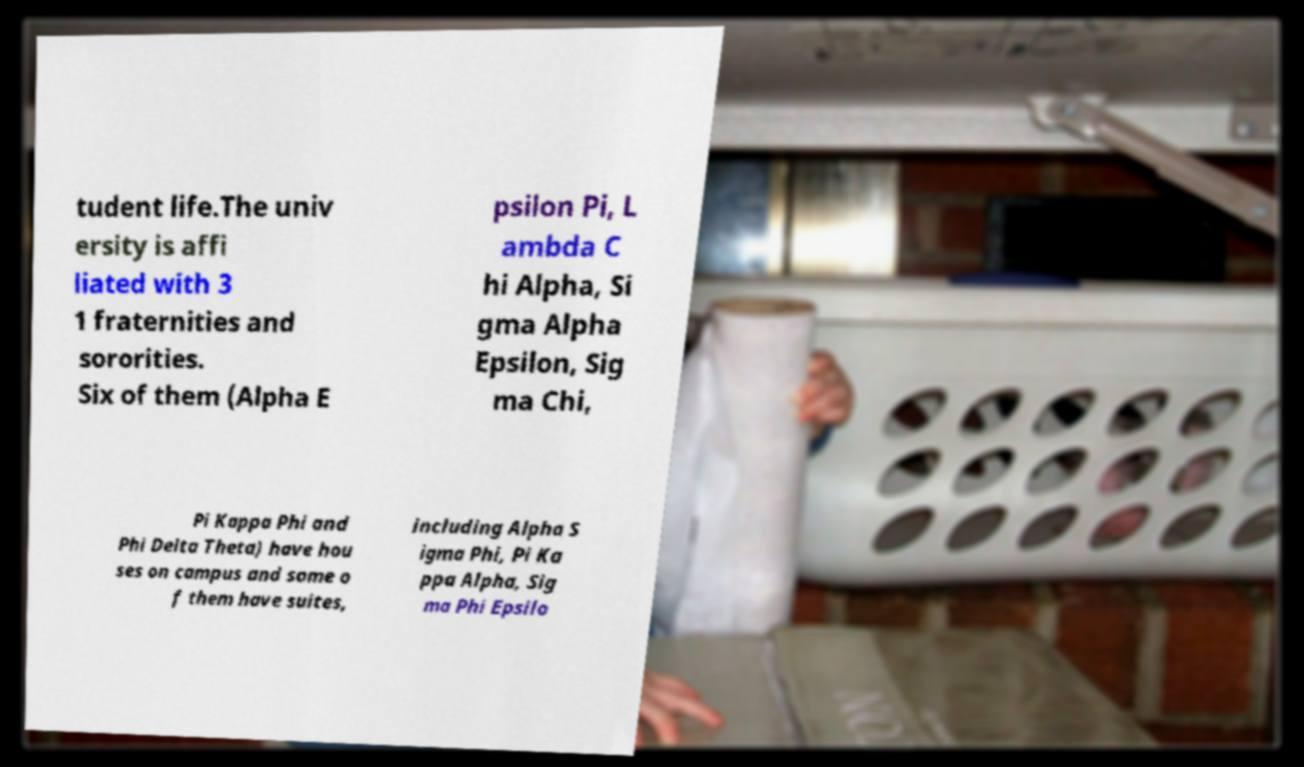Can you read and provide the text displayed in the image?This photo seems to have some interesting text. Can you extract and type it out for me? tudent life.The univ ersity is affi liated with 3 1 fraternities and sororities. Six of them (Alpha E psilon Pi, L ambda C hi Alpha, Si gma Alpha Epsilon, Sig ma Chi, Pi Kappa Phi and Phi Delta Theta) have hou ses on campus and some o f them have suites, including Alpha S igma Phi, Pi Ka ppa Alpha, Sig ma Phi Epsilo 